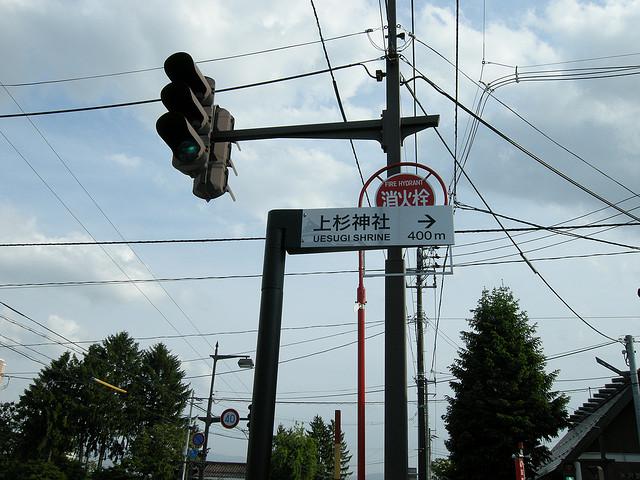What type of building is in the bottom right corner of the picture?
Short answer required. House. What way is the black arrow pointing?
Write a very short answer. Right. Is there more than one language on the sign?
Concise answer only. Yes. 